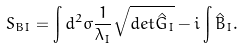<formula> <loc_0><loc_0><loc_500><loc_500>S _ { B I } = \int d ^ { 2 } \sigma \frac { 1 } { \lambda _ { I } } \sqrt { d e t \hat { G } _ { I } } - i \int \hat { B } _ { I } .</formula> 